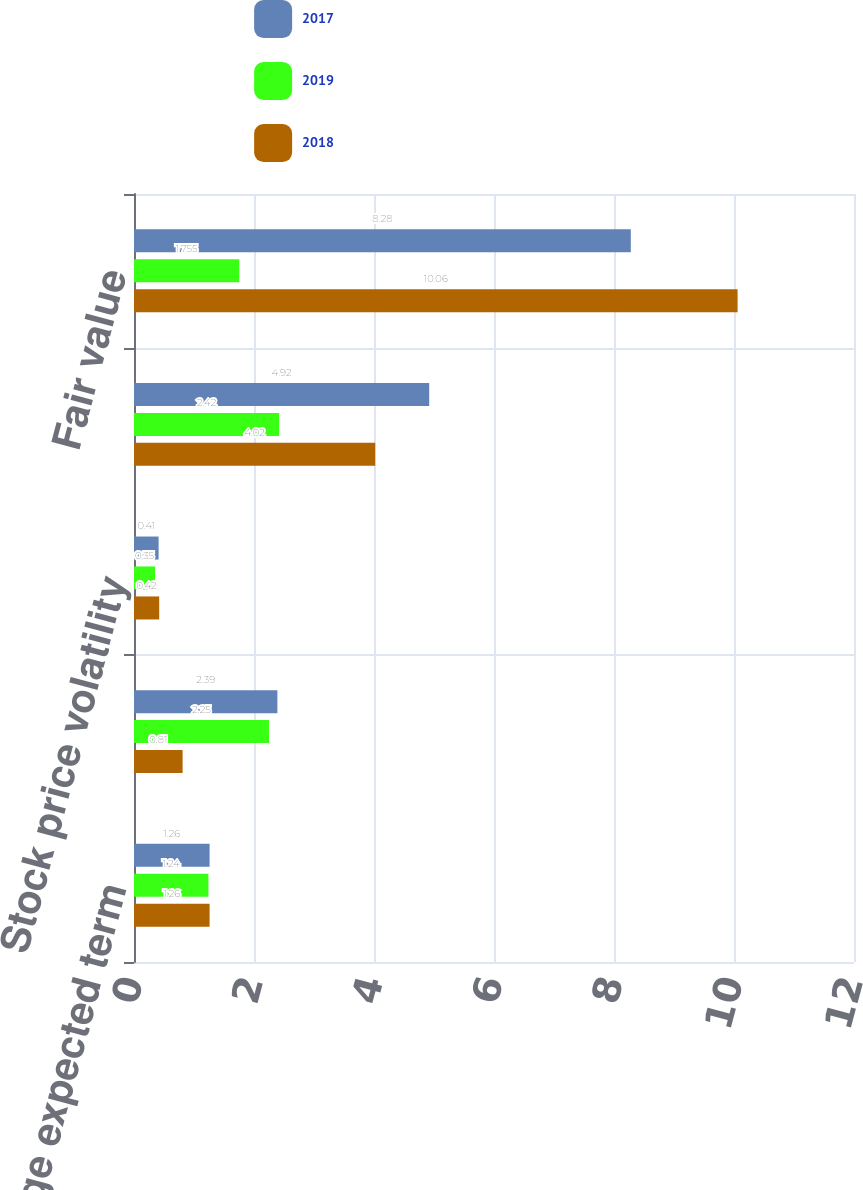<chart> <loc_0><loc_0><loc_500><loc_500><stacked_bar_chart><ecel><fcel>Weighted-average expected term<fcel>Risk-free interest rate<fcel>Stock price volatility<fcel>Dividend yield<fcel>Fair value<nl><fcel>2017<fcel>1.26<fcel>2.39<fcel>0.41<fcel>4.92<fcel>8.28<nl><fcel>2019<fcel>1.24<fcel>2.25<fcel>0.35<fcel>2.42<fcel>1.755<nl><fcel>2018<fcel>1.26<fcel>0.81<fcel>0.42<fcel>4.02<fcel>10.06<nl></chart> 